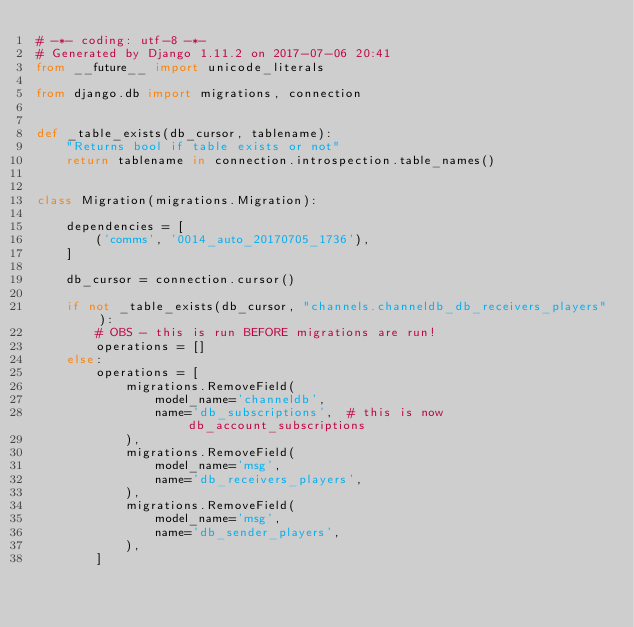<code> <loc_0><loc_0><loc_500><loc_500><_Python_># -*- coding: utf-8 -*-
# Generated by Django 1.11.2 on 2017-07-06 20:41
from __future__ import unicode_literals

from django.db import migrations, connection


def _table_exists(db_cursor, tablename):
    "Returns bool if table exists or not"
    return tablename in connection.introspection.table_names()


class Migration(migrations.Migration):

    dependencies = [
        ('comms', '0014_auto_20170705_1736'),
    ]

    db_cursor = connection.cursor()

    if not _table_exists(db_cursor, "channels.channeldb_db_receivers_players"):
        # OBS - this is run BEFORE migrations are run!
        operations = []
    else:
        operations = [
            migrations.RemoveField(
                model_name='channeldb',
                name='db_subscriptions',  # this is now db_account_subscriptions
            ),
            migrations.RemoveField(
                model_name='msg',
                name='db_receivers_players',
            ),
            migrations.RemoveField(
                model_name='msg',
                name='db_sender_players',
            ),
        ]
</code> 